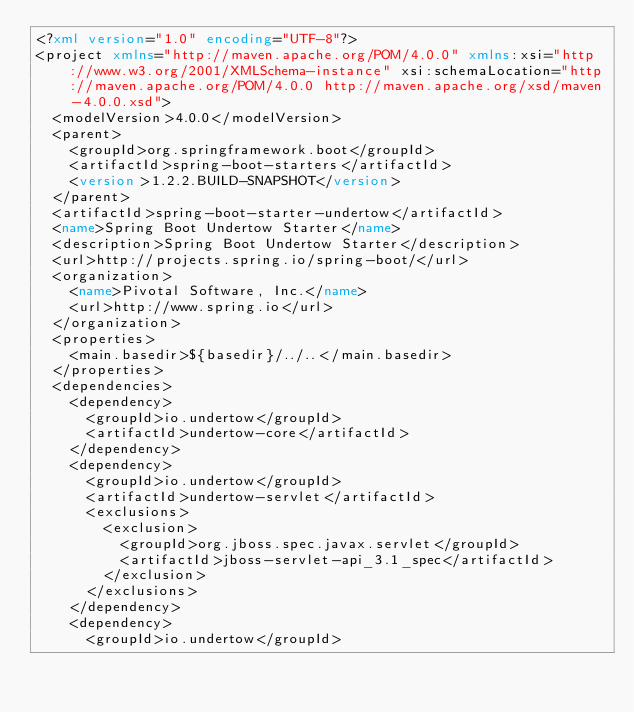<code> <loc_0><loc_0><loc_500><loc_500><_XML_><?xml version="1.0" encoding="UTF-8"?>
<project xmlns="http://maven.apache.org/POM/4.0.0" xmlns:xsi="http://www.w3.org/2001/XMLSchema-instance" xsi:schemaLocation="http://maven.apache.org/POM/4.0.0 http://maven.apache.org/xsd/maven-4.0.0.xsd">
	<modelVersion>4.0.0</modelVersion>
	<parent>
		<groupId>org.springframework.boot</groupId>
		<artifactId>spring-boot-starters</artifactId>
		<version>1.2.2.BUILD-SNAPSHOT</version>
	</parent>
	<artifactId>spring-boot-starter-undertow</artifactId>
	<name>Spring Boot Undertow Starter</name>
	<description>Spring Boot Undertow Starter</description>
	<url>http://projects.spring.io/spring-boot/</url>
	<organization>
		<name>Pivotal Software, Inc.</name>
		<url>http://www.spring.io</url>
	</organization>
	<properties>
		<main.basedir>${basedir}/../..</main.basedir>
	</properties>
	<dependencies>
		<dependency>
			<groupId>io.undertow</groupId>
			<artifactId>undertow-core</artifactId>
		</dependency>
		<dependency>
			<groupId>io.undertow</groupId>
			<artifactId>undertow-servlet</artifactId>
			<exclusions>
				<exclusion>
					<groupId>org.jboss.spec.javax.servlet</groupId>
					<artifactId>jboss-servlet-api_3.1_spec</artifactId>
				</exclusion>
			</exclusions>
		</dependency>
		<dependency>
			<groupId>io.undertow</groupId></code> 